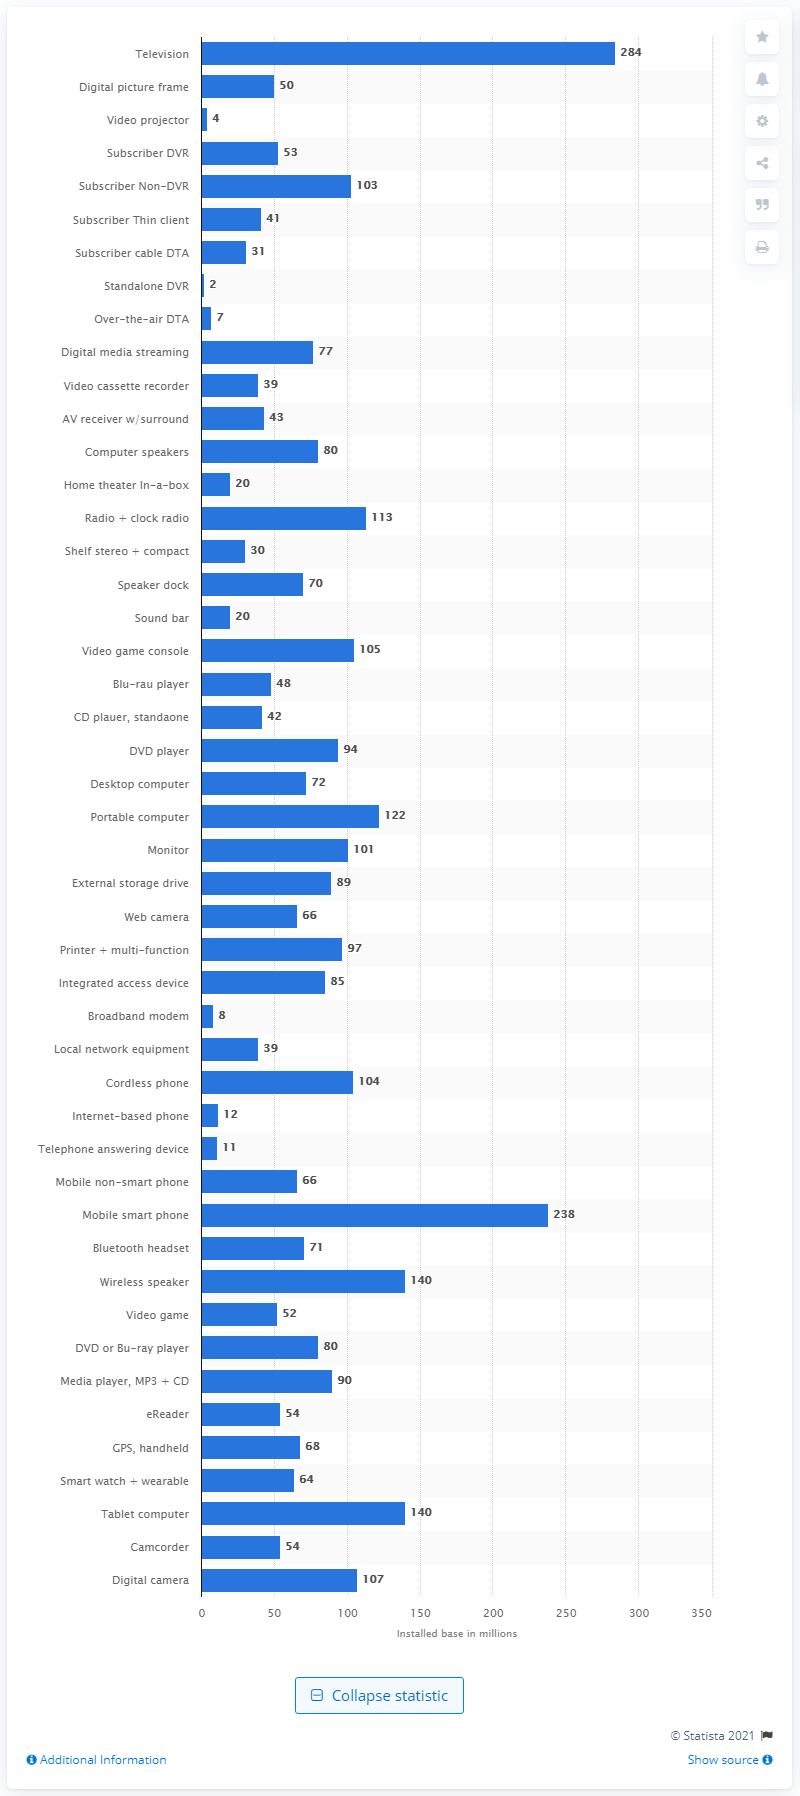Mention a couple of crucial points in this snapshot. In 2017, there were approximately 66 million web cameras installed in the United States. 